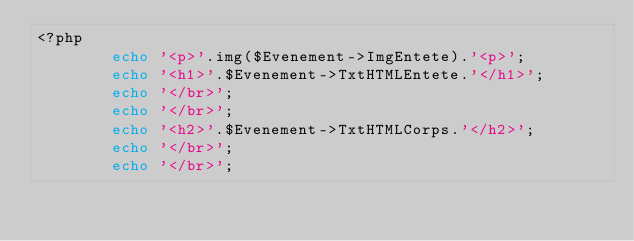<code> <loc_0><loc_0><loc_500><loc_500><_PHP_><?php
        echo '<p>'.img($Evenement->ImgEntete).'<p>';
        echo '<h1>'.$Evenement->TxtHTMLEntete.'</h1>';
        echo '</br>';
        echo '</br>';
        echo '<h2>'.$Evenement->TxtHTMLCorps.'</h2>';
        echo '</br>';
        echo '</br>';
    
</code> 